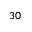Convert formula to latex. <formula><loc_0><loc_0><loc_500><loc_500>3 0</formula> 